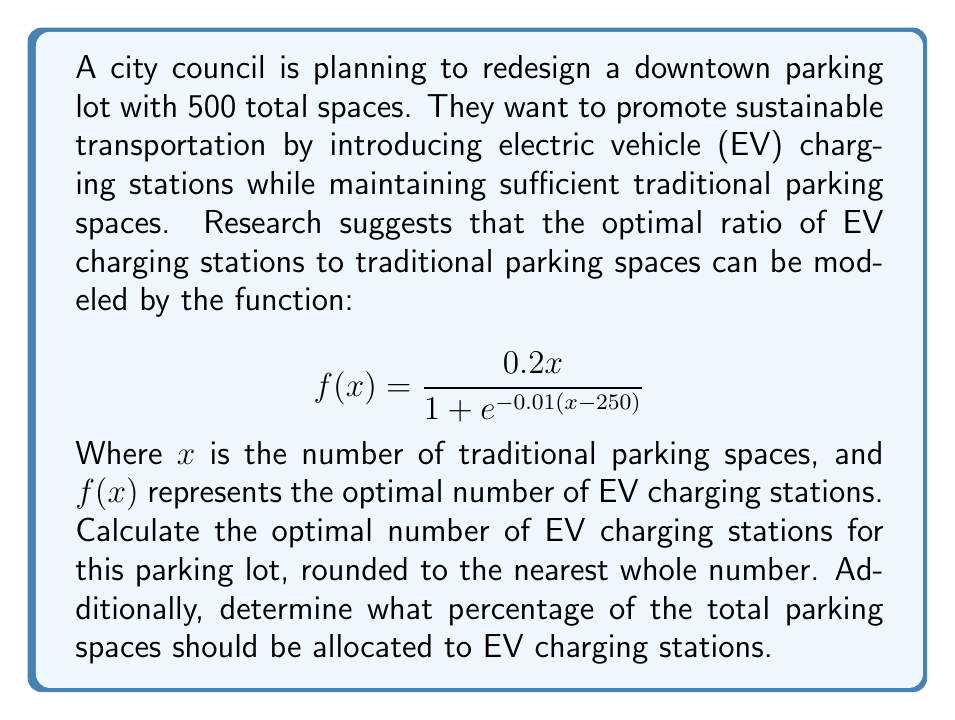Teach me how to tackle this problem. To solve this problem, we need to follow these steps:

1) First, we need to determine the number of traditional parking spaces ($x$). Since the total number of spaces is 500, and we're looking for the optimal ratio, we can use:

   $x + f(x) = 500$

2) Substituting the given function:

   $x + \frac{0.2x}{1 + e^{-0.01(x-250)}} = 500$

3) This equation is difficult to solve analytically, so we'll use an iterative approach. Let's start with $x = 400$ and adjust:

   $400 + \frac{0.2(400)}{1 + e^{-0.01(400-250)}} = 400 + 73.62 = 473.62$

4) This is too low, so let's try $x = 425$:

   $425 + \frac{0.2(425)}{1 + e^{-0.01(425-250)}} = 425 + 79.76 = 504.76$

5) This is close, but slightly too high. After a few more iterations, we find that $x \approx 422$ gives us:

   $422 + \frac{0.2(422)}{1 + e^{-0.01(422-250)}} = 422 + 78.00 = 500.00$

6) Therefore, the optimal number of EV charging stations is approximately 78.

7) To calculate the percentage of total spaces allocated to EV charging:

   $\frac{78}{500} \times 100\% = 15.6\%$
Answer: The optimal number of EV charging stations is 78 (rounded to the nearest whole number). This represents 15.6% of the total parking spaces. 